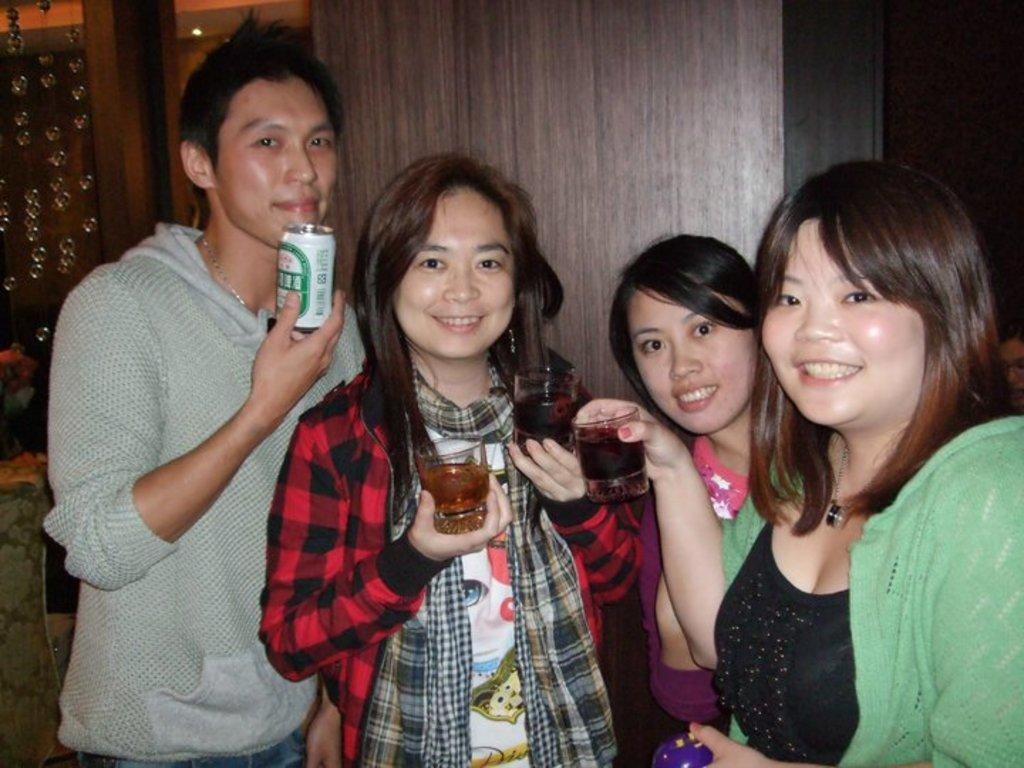What are the people in the image doing? The people in the image are standing in the middle of the image and smiling. What objects are the people holding in the image? The people are holding glasses and tins in the image. What can be seen in the background of the image? There is a wooden wall in the background of the image. What type of hammer can be seen being used by the people in the image? There is no hammer present in the image; the people are holding glasses and tins. Can you describe the flooring in the hall where the people are standing? There is no mention of a hall in the image, and the flooring is not visible in the provided facts. 